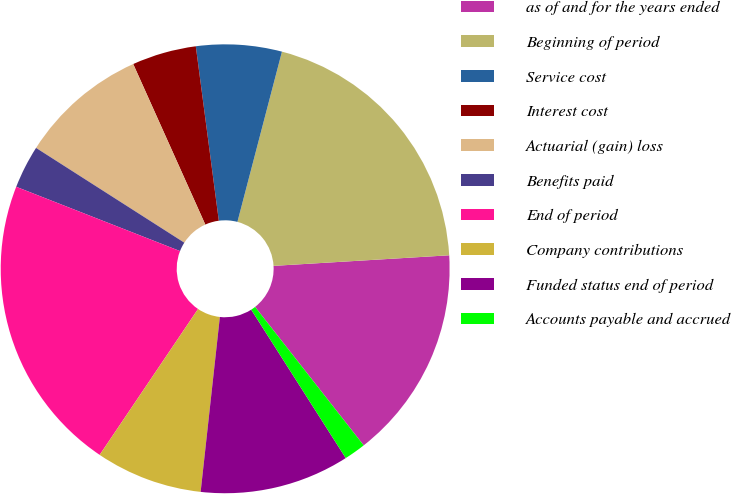<chart> <loc_0><loc_0><loc_500><loc_500><pie_chart><fcel>as of and for the years ended<fcel>Beginning of period<fcel>Service cost<fcel>Interest cost<fcel>Actuarial (gain) loss<fcel>Benefits paid<fcel>End of period<fcel>Company contributions<fcel>Funded status end of period<fcel>Accounts payable and accrued<nl><fcel>15.37%<fcel>19.97%<fcel>6.16%<fcel>4.63%<fcel>9.23%<fcel>3.1%<fcel>21.51%<fcel>7.7%<fcel>10.77%<fcel>1.56%<nl></chart> 